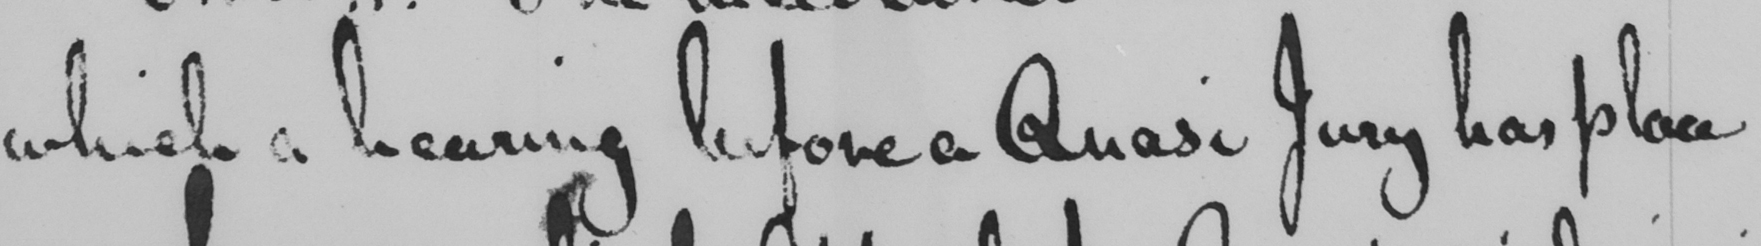Can you tell me what this handwritten text says? which a hearing before a Quasi Jury has place 